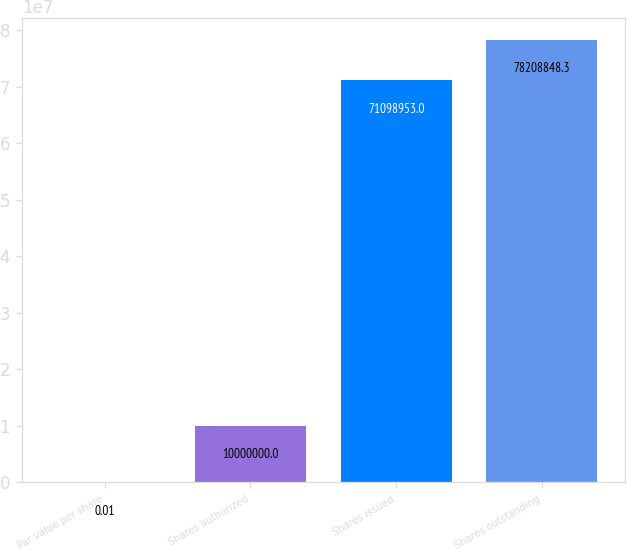Convert chart. <chart><loc_0><loc_0><loc_500><loc_500><bar_chart><fcel>Par value per share<fcel>Shares authorized<fcel>Shares issued<fcel>Shares outstanding<nl><fcel>0.01<fcel>1e+07<fcel>7.1099e+07<fcel>7.82088e+07<nl></chart> 